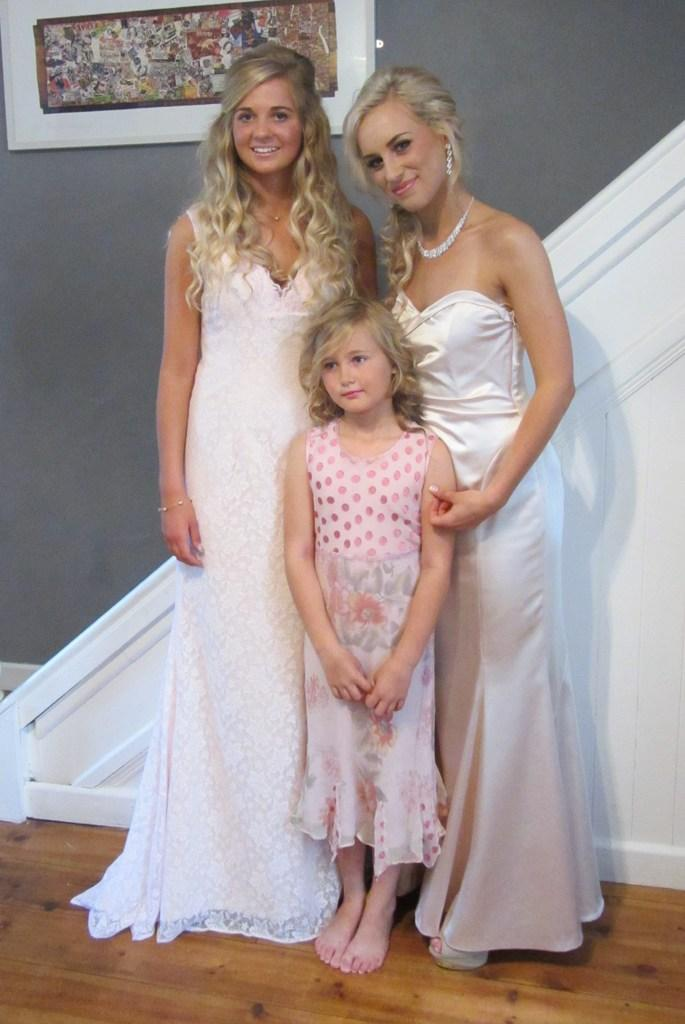How many people are in the image? There are three people in the image. Where are the people located in the image? The people are on the floor. What can be seen in the background of the image? There is a photo frame on the wall in the background of the image. What type of engine is visible in the image? There is no engine present in the image. What scientific experiment is being conducted in the image? There is no scientific experiment being conducted in the image. 